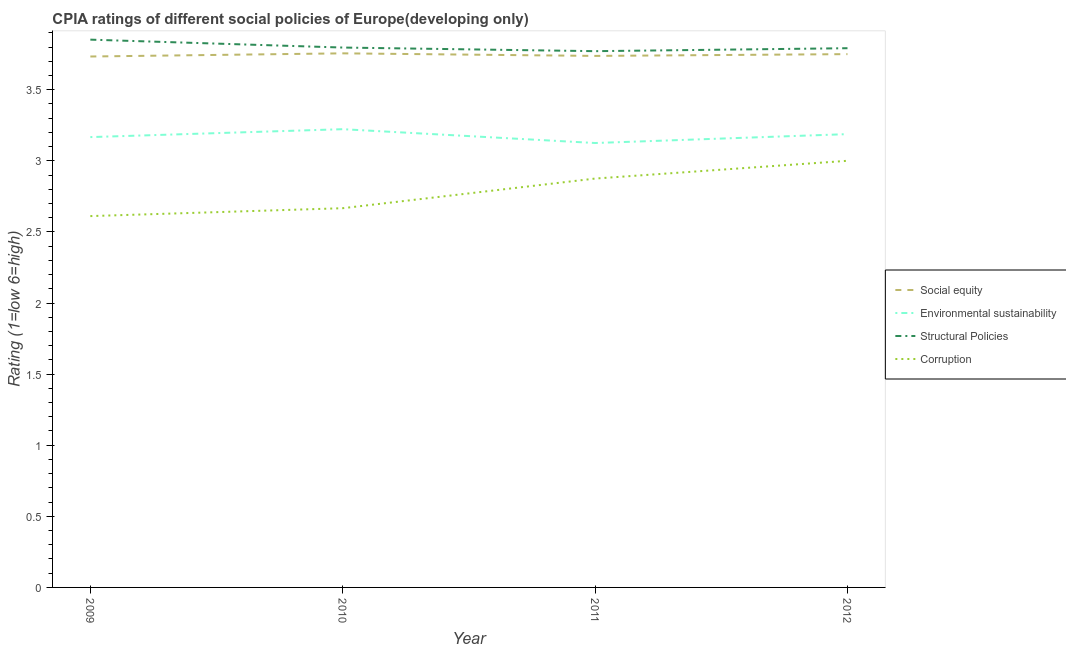How many different coloured lines are there?
Ensure brevity in your answer.  4. Does the line corresponding to cpia rating of environmental sustainability intersect with the line corresponding to cpia rating of social equity?
Provide a succinct answer. No. What is the cpia rating of social equity in 2011?
Your answer should be compact. 3.74. Across all years, what is the maximum cpia rating of structural policies?
Your response must be concise. 3.85. Across all years, what is the minimum cpia rating of social equity?
Provide a succinct answer. 3.73. In which year was the cpia rating of environmental sustainability maximum?
Give a very brief answer. 2010. In which year was the cpia rating of structural policies minimum?
Give a very brief answer. 2011. What is the total cpia rating of structural policies in the graph?
Ensure brevity in your answer.  15.21. What is the difference between the cpia rating of environmental sustainability in 2010 and that in 2012?
Offer a very short reply. 0.03. What is the difference between the cpia rating of structural policies in 2009 and the cpia rating of corruption in 2012?
Your response must be concise. 0.85. What is the average cpia rating of social equity per year?
Your response must be concise. 3.74. In the year 2009, what is the difference between the cpia rating of structural policies and cpia rating of corruption?
Offer a terse response. 1.24. In how many years, is the cpia rating of environmental sustainability greater than 3.1?
Make the answer very short. 4. What is the ratio of the cpia rating of social equity in 2010 to that in 2011?
Provide a short and direct response. 1. Is the cpia rating of corruption in 2011 less than that in 2012?
Your response must be concise. Yes. What is the difference between the highest and the second highest cpia rating of social equity?
Offer a terse response. 0.01. What is the difference between the highest and the lowest cpia rating of corruption?
Ensure brevity in your answer.  0.39. In how many years, is the cpia rating of environmental sustainability greater than the average cpia rating of environmental sustainability taken over all years?
Offer a terse response. 2. Is the sum of the cpia rating of corruption in 2010 and 2012 greater than the maximum cpia rating of structural policies across all years?
Offer a terse response. Yes. Is the cpia rating of structural policies strictly greater than the cpia rating of social equity over the years?
Offer a very short reply. Yes. Is the cpia rating of structural policies strictly less than the cpia rating of corruption over the years?
Your answer should be compact. No. How many lines are there?
Provide a short and direct response. 4. How many years are there in the graph?
Your response must be concise. 4. Where does the legend appear in the graph?
Offer a very short reply. Center right. How many legend labels are there?
Your answer should be very brief. 4. What is the title of the graph?
Your answer should be compact. CPIA ratings of different social policies of Europe(developing only). What is the Rating (1=low 6=high) of Social equity in 2009?
Provide a succinct answer. 3.73. What is the Rating (1=low 6=high) of Environmental sustainability in 2009?
Your answer should be compact. 3.17. What is the Rating (1=low 6=high) of Structural Policies in 2009?
Provide a succinct answer. 3.85. What is the Rating (1=low 6=high) of Corruption in 2009?
Provide a short and direct response. 2.61. What is the Rating (1=low 6=high) in Social equity in 2010?
Keep it short and to the point. 3.76. What is the Rating (1=low 6=high) of Environmental sustainability in 2010?
Offer a very short reply. 3.22. What is the Rating (1=low 6=high) of Structural Policies in 2010?
Offer a terse response. 3.8. What is the Rating (1=low 6=high) of Corruption in 2010?
Keep it short and to the point. 2.67. What is the Rating (1=low 6=high) of Social equity in 2011?
Provide a short and direct response. 3.74. What is the Rating (1=low 6=high) of Environmental sustainability in 2011?
Provide a short and direct response. 3.12. What is the Rating (1=low 6=high) in Structural Policies in 2011?
Provide a succinct answer. 3.77. What is the Rating (1=low 6=high) of Corruption in 2011?
Provide a short and direct response. 2.88. What is the Rating (1=low 6=high) of Social equity in 2012?
Your answer should be compact. 3.75. What is the Rating (1=low 6=high) in Environmental sustainability in 2012?
Ensure brevity in your answer.  3.19. What is the Rating (1=low 6=high) in Structural Policies in 2012?
Provide a succinct answer. 3.79. What is the Rating (1=low 6=high) in Corruption in 2012?
Give a very brief answer. 3. Across all years, what is the maximum Rating (1=low 6=high) of Social equity?
Provide a succinct answer. 3.76. Across all years, what is the maximum Rating (1=low 6=high) of Environmental sustainability?
Give a very brief answer. 3.22. Across all years, what is the maximum Rating (1=low 6=high) of Structural Policies?
Provide a succinct answer. 3.85. Across all years, what is the maximum Rating (1=low 6=high) of Corruption?
Keep it short and to the point. 3. Across all years, what is the minimum Rating (1=low 6=high) in Social equity?
Your answer should be very brief. 3.73. Across all years, what is the minimum Rating (1=low 6=high) in Environmental sustainability?
Your response must be concise. 3.12. Across all years, what is the minimum Rating (1=low 6=high) in Structural Policies?
Your answer should be very brief. 3.77. Across all years, what is the minimum Rating (1=low 6=high) of Corruption?
Offer a very short reply. 2.61. What is the total Rating (1=low 6=high) in Social equity in the graph?
Your answer should be compact. 14.98. What is the total Rating (1=low 6=high) in Environmental sustainability in the graph?
Your answer should be very brief. 12.7. What is the total Rating (1=low 6=high) in Structural Policies in the graph?
Offer a very short reply. 15.21. What is the total Rating (1=low 6=high) in Corruption in the graph?
Keep it short and to the point. 11.15. What is the difference between the Rating (1=low 6=high) in Social equity in 2009 and that in 2010?
Give a very brief answer. -0.02. What is the difference between the Rating (1=low 6=high) of Environmental sustainability in 2009 and that in 2010?
Keep it short and to the point. -0.06. What is the difference between the Rating (1=low 6=high) in Structural Policies in 2009 and that in 2010?
Your answer should be very brief. 0.06. What is the difference between the Rating (1=low 6=high) of Corruption in 2009 and that in 2010?
Offer a terse response. -0.06. What is the difference between the Rating (1=low 6=high) of Social equity in 2009 and that in 2011?
Offer a terse response. -0. What is the difference between the Rating (1=low 6=high) of Environmental sustainability in 2009 and that in 2011?
Offer a very short reply. 0.04. What is the difference between the Rating (1=low 6=high) of Structural Policies in 2009 and that in 2011?
Your response must be concise. 0.08. What is the difference between the Rating (1=low 6=high) in Corruption in 2009 and that in 2011?
Ensure brevity in your answer.  -0.26. What is the difference between the Rating (1=low 6=high) in Social equity in 2009 and that in 2012?
Provide a succinct answer. -0.02. What is the difference between the Rating (1=low 6=high) in Environmental sustainability in 2009 and that in 2012?
Your response must be concise. -0.02. What is the difference between the Rating (1=low 6=high) in Structural Policies in 2009 and that in 2012?
Keep it short and to the point. 0.06. What is the difference between the Rating (1=low 6=high) in Corruption in 2009 and that in 2012?
Offer a terse response. -0.39. What is the difference between the Rating (1=low 6=high) in Social equity in 2010 and that in 2011?
Give a very brief answer. 0.02. What is the difference between the Rating (1=low 6=high) of Environmental sustainability in 2010 and that in 2011?
Provide a succinct answer. 0.1. What is the difference between the Rating (1=low 6=high) of Structural Policies in 2010 and that in 2011?
Provide a short and direct response. 0.03. What is the difference between the Rating (1=low 6=high) in Corruption in 2010 and that in 2011?
Ensure brevity in your answer.  -0.21. What is the difference between the Rating (1=low 6=high) of Social equity in 2010 and that in 2012?
Ensure brevity in your answer.  0.01. What is the difference between the Rating (1=low 6=high) of Environmental sustainability in 2010 and that in 2012?
Ensure brevity in your answer.  0.03. What is the difference between the Rating (1=low 6=high) of Structural Policies in 2010 and that in 2012?
Your response must be concise. 0. What is the difference between the Rating (1=low 6=high) in Social equity in 2011 and that in 2012?
Keep it short and to the point. -0.01. What is the difference between the Rating (1=low 6=high) in Environmental sustainability in 2011 and that in 2012?
Keep it short and to the point. -0.06. What is the difference between the Rating (1=low 6=high) in Structural Policies in 2011 and that in 2012?
Offer a terse response. -0.02. What is the difference between the Rating (1=low 6=high) of Corruption in 2011 and that in 2012?
Ensure brevity in your answer.  -0.12. What is the difference between the Rating (1=low 6=high) in Social equity in 2009 and the Rating (1=low 6=high) in Environmental sustainability in 2010?
Your answer should be compact. 0.51. What is the difference between the Rating (1=low 6=high) of Social equity in 2009 and the Rating (1=low 6=high) of Structural Policies in 2010?
Provide a succinct answer. -0.06. What is the difference between the Rating (1=low 6=high) of Social equity in 2009 and the Rating (1=low 6=high) of Corruption in 2010?
Offer a terse response. 1.07. What is the difference between the Rating (1=low 6=high) in Environmental sustainability in 2009 and the Rating (1=low 6=high) in Structural Policies in 2010?
Your answer should be very brief. -0.63. What is the difference between the Rating (1=low 6=high) in Environmental sustainability in 2009 and the Rating (1=low 6=high) in Corruption in 2010?
Give a very brief answer. 0.5. What is the difference between the Rating (1=low 6=high) in Structural Policies in 2009 and the Rating (1=low 6=high) in Corruption in 2010?
Your response must be concise. 1.19. What is the difference between the Rating (1=low 6=high) of Social equity in 2009 and the Rating (1=low 6=high) of Environmental sustainability in 2011?
Provide a succinct answer. 0.61. What is the difference between the Rating (1=low 6=high) in Social equity in 2009 and the Rating (1=low 6=high) in Structural Policies in 2011?
Provide a succinct answer. -0.04. What is the difference between the Rating (1=low 6=high) of Social equity in 2009 and the Rating (1=low 6=high) of Corruption in 2011?
Provide a succinct answer. 0.86. What is the difference between the Rating (1=low 6=high) in Environmental sustainability in 2009 and the Rating (1=low 6=high) in Structural Policies in 2011?
Your response must be concise. -0.6. What is the difference between the Rating (1=low 6=high) of Environmental sustainability in 2009 and the Rating (1=low 6=high) of Corruption in 2011?
Your response must be concise. 0.29. What is the difference between the Rating (1=low 6=high) of Structural Policies in 2009 and the Rating (1=low 6=high) of Corruption in 2011?
Offer a terse response. 0.98. What is the difference between the Rating (1=low 6=high) of Social equity in 2009 and the Rating (1=low 6=high) of Environmental sustainability in 2012?
Your response must be concise. 0.55. What is the difference between the Rating (1=low 6=high) of Social equity in 2009 and the Rating (1=low 6=high) of Structural Policies in 2012?
Offer a terse response. -0.06. What is the difference between the Rating (1=low 6=high) of Social equity in 2009 and the Rating (1=low 6=high) of Corruption in 2012?
Ensure brevity in your answer.  0.73. What is the difference between the Rating (1=low 6=high) of Environmental sustainability in 2009 and the Rating (1=low 6=high) of Structural Policies in 2012?
Offer a very short reply. -0.62. What is the difference between the Rating (1=low 6=high) of Structural Policies in 2009 and the Rating (1=low 6=high) of Corruption in 2012?
Offer a terse response. 0.85. What is the difference between the Rating (1=low 6=high) in Social equity in 2010 and the Rating (1=low 6=high) in Environmental sustainability in 2011?
Provide a short and direct response. 0.63. What is the difference between the Rating (1=low 6=high) of Social equity in 2010 and the Rating (1=low 6=high) of Structural Policies in 2011?
Your answer should be very brief. -0.02. What is the difference between the Rating (1=low 6=high) in Social equity in 2010 and the Rating (1=low 6=high) in Corruption in 2011?
Provide a succinct answer. 0.88. What is the difference between the Rating (1=low 6=high) of Environmental sustainability in 2010 and the Rating (1=low 6=high) of Structural Policies in 2011?
Keep it short and to the point. -0.55. What is the difference between the Rating (1=low 6=high) in Environmental sustainability in 2010 and the Rating (1=low 6=high) in Corruption in 2011?
Give a very brief answer. 0.35. What is the difference between the Rating (1=low 6=high) of Structural Policies in 2010 and the Rating (1=low 6=high) of Corruption in 2011?
Offer a terse response. 0.92. What is the difference between the Rating (1=low 6=high) of Social equity in 2010 and the Rating (1=low 6=high) of Environmental sustainability in 2012?
Give a very brief answer. 0.57. What is the difference between the Rating (1=low 6=high) in Social equity in 2010 and the Rating (1=low 6=high) in Structural Policies in 2012?
Provide a succinct answer. -0.04. What is the difference between the Rating (1=low 6=high) in Social equity in 2010 and the Rating (1=low 6=high) in Corruption in 2012?
Make the answer very short. 0.76. What is the difference between the Rating (1=low 6=high) of Environmental sustainability in 2010 and the Rating (1=low 6=high) of Structural Policies in 2012?
Offer a very short reply. -0.57. What is the difference between the Rating (1=low 6=high) of Environmental sustainability in 2010 and the Rating (1=low 6=high) of Corruption in 2012?
Your answer should be very brief. 0.22. What is the difference between the Rating (1=low 6=high) of Structural Policies in 2010 and the Rating (1=low 6=high) of Corruption in 2012?
Ensure brevity in your answer.  0.8. What is the difference between the Rating (1=low 6=high) in Social equity in 2011 and the Rating (1=low 6=high) in Environmental sustainability in 2012?
Offer a very short reply. 0.55. What is the difference between the Rating (1=low 6=high) in Social equity in 2011 and the Rating (1=low 6=high) in Structural Policies in 2012?
Provide a short and direct response. -0.05. What is the difference between the Rating (1=low 6=high) of Social equity in 2011 and the Rating (1=low 6=high) of Corruption in 2012?
Make the answer very short. 0.74. What is the difference between the Rating (1=low 6=high) of Environmental sustainability in 2011 and the Rating (1=low 6=high) of Structural Policies in 2012?
Make the answer very short. -0.67. What is the difference between the Rating (1=low 6=high) in Environmental sustainability in 2011 and the Rating (1=low 6=high) in Corruption in 2012?
Make the answer very short. 0.12. What is the difference between the Rating (1=low 6=high) of Structural Policies in 2011 and the Rating (1=low 6=high) of Corruption in 2012?
Provide a short and direct response. 0.77. What is the average Rating (1=low 6=high) of Social equity per year?
Ensure brevity in your answer.  3.74. What is the average Rating (1=low 6=high) of Environmental sustainability per year?
Make the answer very short. 3.18. What is the average Rating (1=low 6=high) of Structural Policies per year?
Provide a short and direct response. 3.8. What is the average Rating (1=low 6=high) of Corruption per year?
Provide a short and direct response. 2.79. In the year 2009, what is the difference between the Rating (1=low 6=high) in Social equity and Rating (1=low 6=high) in Environmental sustainability?
Provide a succinct answer. 0.57. In the year 2009, what is the difference between the Rating (1=low 6=high) in Social equity and Rating (1=low 6=high) in Structural Policies?
Keep it short and to the point. -0.12. In the year 2009, what is the difference between the Rating (1=low 6=high) of Social equity and Rating (1=low 6=high) of Corruption?
Your answer should be very brief. 1.12. In the year 2009, what is the difference between the Rating (1=low 6=high) of Environmental sustainability and Rating (1=low 6=high) of Structural Policies?
Provide a succinct answer. -0.69. In the year 2009, what is the difference between the Rating (1=low 6=high) in Environmental sustainability and Rating (1=low 6=high) in Corruption?
Give a very brief answer. 0.56. In the year 2009, what is the difference between the Rating (1=low 6=high) in Structural Policies and Rating (1=low 6=high) in Corruption?
Keep it short and to the point. 1.24. In the year 2010, what is the difference between the Rating (1=low 6=high) of Social equity and Rating (1=low 6=high) of Environmental sustainability?
Give a very brief answer. 0.53. In the year 2010, what is the difference between the Rating (1=low 6=high) in Social equity and Rating (1=low 6=high) in Structural Policies?
Give a very brief answer. -0.04. In the year 2010, what is the difference between the Rating (1=low 6=high) of Social equity and Rating (1=low 6=high) of Corruption?
Provide a short and direct response. 1.09. In the year 2010, what is the difference between the Rating (1=low 6=high) in Environmental sustainability and Rating (1=low 6=high) in Structural Policies?
Provide a short and direct response. -0.57. In the year 2010, what is the difference between the Rating (1=low 6=high) of Environmental sustainability and Rating (1=low 6=high) of Corruption?
Provide a succinct answer. 0.56. In the year 2010, what is the difference between the Rating (1=low 6=high) in Structural Policies and Rating (1=low 6=high) in Corruption?
Provide a short and direct response. 1.13. In the year 2011, what is the difference between the Rating (1=low 6=high) of Social equity and Rating (1=low 6=high) of Environmental sustainability?
Your answer should be very brief. 0.61. In the year 2011, what is the difference between the Rating (1=low 6=high) of Social equity and Rating (1=low 6=high) of Structural Policies?
Your answer should be compact. -0.03. In the year 2011, what is the difference between the Rating (1=low 6=high) of Social equity and Rating (1=low 6=high) of Corruption?
Your answer should be very brief. 0.86. In the year 2011, what is the difference between the Rating (1=low 6=high) of Environmental sustainability and Rating (1=low 6=high) of Structural Policies?
Give a very brief answer. -0.65. In the year 2011, what is the difference between the Rating (1=low 6=high) of Structural Policies and Rating (1=low 6=high) of Corruption?
Your answer should be very brief. 0.9. In the year 2012, what is the difference between the Rating (1=low 6=high) in Social equity and Rating (1=low 6=high) in Environmental sustainability?
Keep it short and to the point. 0.56. In the year 2012, what is the difference between the Rating (1=low 6=high) in Social equity and Rating (1=low 6=high) in Structural Policies?
Ensure brevity in your answer.  -0.04. In the year 2012, what is the difference between the Rating (1=low 6=high) in Social equity and Rating (1=low 6=high) in Corruption?
Your answer should be very brief. 0.75. In the year 2012, what is the difference between the Rating (1=low 6=high) in Environmental sustainability and Rating (1=low 6=high) in Structural Policies?
Provide a succinct answer. -0.6. In the year 2012, what is the difference between the Rating (1=low 6=high) in Environmental sustainability and Rating (1=low 6=high) in Corruption?
Provide a short and direct response. 0.19. In the year 2012, what is the difference between the Rating (1=low 6=high) in Structural Policies and Rating (1=low 6=high) in Corruption?
Give a very brief answer. 0.79. What is the ratio of the Rating (1=low 6=high) of Environmental sustainability in 2009 to that in 2010?
Your response must be concise. 0.98. What is the ratio of the Rating (1=low 6=high) in Structural Policies in 2009 to that in 2010?
Your answer should be compact. 1.01. What is the ratio of the Rating (1=low 6=high) of Corruption in 2009 to that in 2010?
Your response must be concise. 0.98. What is the ratio of the Rating (1=low 6=high) of Environmental sustainability in 2009 to that in 2011?
Ensure brevity in your answer.  1.01. What is the ratio of the Rating (1=low 6=high) in Structural Policies in 2009 to that in 2011?
Give a very brief answer. 1.02. What is the ratio of the Rating (1=low 6=high) of Corruption in 2009 to that in 2011?
Keep it short and to the point. 0.91. What is the ratio of the Rating (1=low 6=high) of Social equity in 2009 to that in 2012?
Your answer should be very brief. 1. What is the ratio of the Rating (1=low 6=high) in Structural Policies in 2009 to that in 2012?
Your answer should be compact. 1.02. What is the ratio of the Rating (1=low 6=high) in Corruption in 2009 to that in 2012?
Offer a terse response. 0.87. What is the ratio of the Rating (1=low 6=high) in Social equity in 2010 to that in 2011?
Provide a short and direct response. 1. What is the ratio of the Rating (1=low 6=high) in Environmental sustainability in 2010 to that in 2011?
Your answer should be compact. 1.03. What is the ratio of the Rating (1=low 6=high) of Structural Policies in 2010 to that in 2011?
Give a very brief answer. 1.01. What is the ratio of the Rating (1=low 6=high) of Corruption in 2010 to that in 2011?
Your answer should be very brief. 0.93. What is the ratio of the Rating (1=low 6=high) in Social equity in 2010 to that in 2012?
Provide a succinct answer. 1. What is the ratio of the Rating (1=low 6=high) of Environmental sustainability in 2010 to that in 2012?
Provide a succinct answer. 1.01. What is the ratio of the Rating (1=low 6=high) of Structural Policies in 2010 to that in 2012?
Ensure brevity in your answer.  1. What is the ratio of the Rating (1=low 6=high) of Environmental sustainability in 2011 to that in 2012?
Your answer should be compact. 0.98. What is the ratio of the Rating (1=low 6=high) in Corruption in 2011 to that in 2012?
Your response must be concise. 0.96. What is the difference between the highest and the second highest Rating (1=low 6=high) in Social equity?
Ensure brevity in your answer.  0.01. What is the difference between the highest and the second highest Rating (1=low 6=high) of Environmental sustainability?
Provide a succinct answer. 0.03. What is the difference between the highest and the second highest Rating (1=low 6=high) of Structural Policies?
Make the answer very short. 0.06. What is the difference between the highest and the lowest Rating (1=low 6=high) in Social equity?
Make the answer very short. 0.02. What is the difference between the highest and the lowest Rating (1=low 6=high) of Environmental sustainability?
Provide a short and direct response. 0.1. What is the difference between the highest and the lowest Rating (1=low 6=high) of Structural Policies?
Keep it short and to the point. 0.08. What is the difference between the highest and the lowest Rating (1=low 6=high) in Corruption?
Provide a succinct answer. 0.39. 